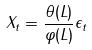Convert formula to latex. <formula><loc_0><loc_0><loc_500><loc_500>X _ { t } = \frac { \theta ( L ) } { \varphi ( L ) } \epsilon _ { t }</formula> 